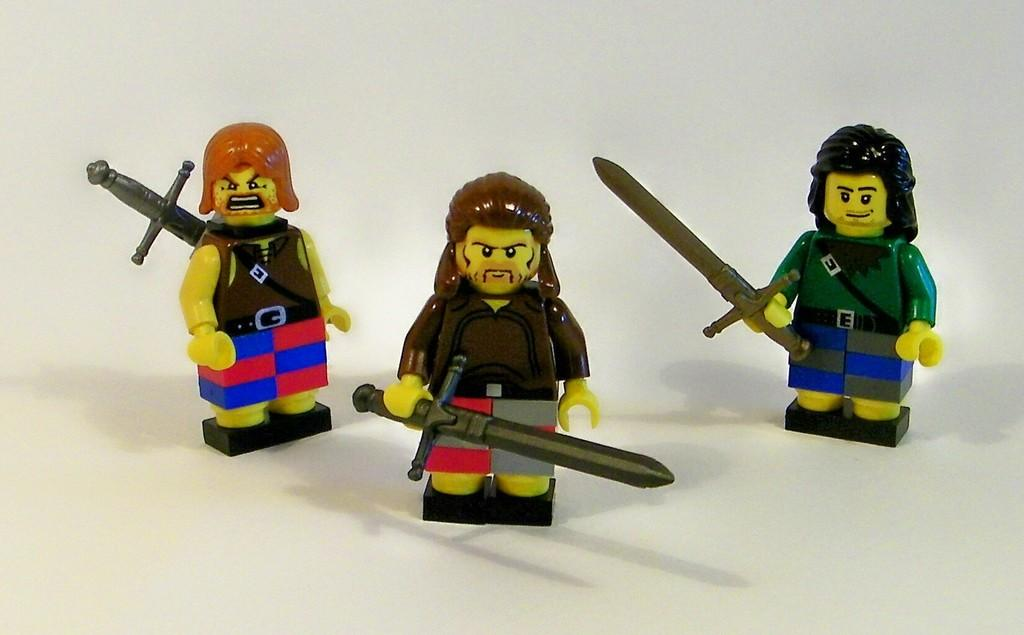How many toys are visible on the white surface in the image? There are three toys on a white surface in the image. What can be observed about the background of the image? The background of the image is white. Are there any tables or chairs visible in the image? No, there are no tables or chairs visible in the image. Is there a pot present in the image? No, there is no pot present in the image. 